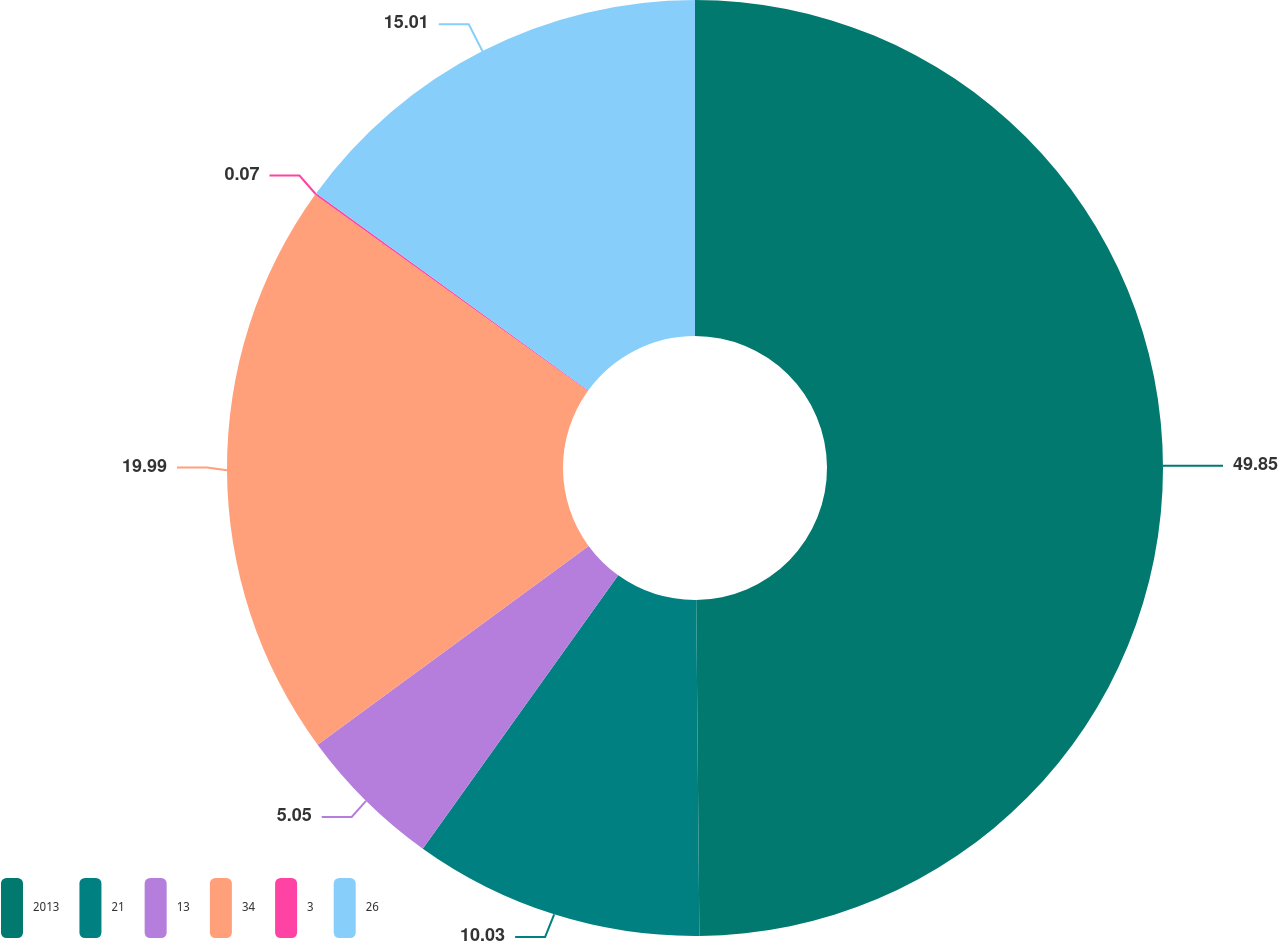<chart> <loc_0><loc_0><loc_500><loc_500><pie_chart><fcel>2013<fcel>21<fcel>13<fcel>34<fcel>3<fcel>26<nl><fcel>49.85%<fcel>10.03%<fcel>5.05%<fcel>19.99%<fcel>0.07%<fcel>15.01%<nl></chart> 